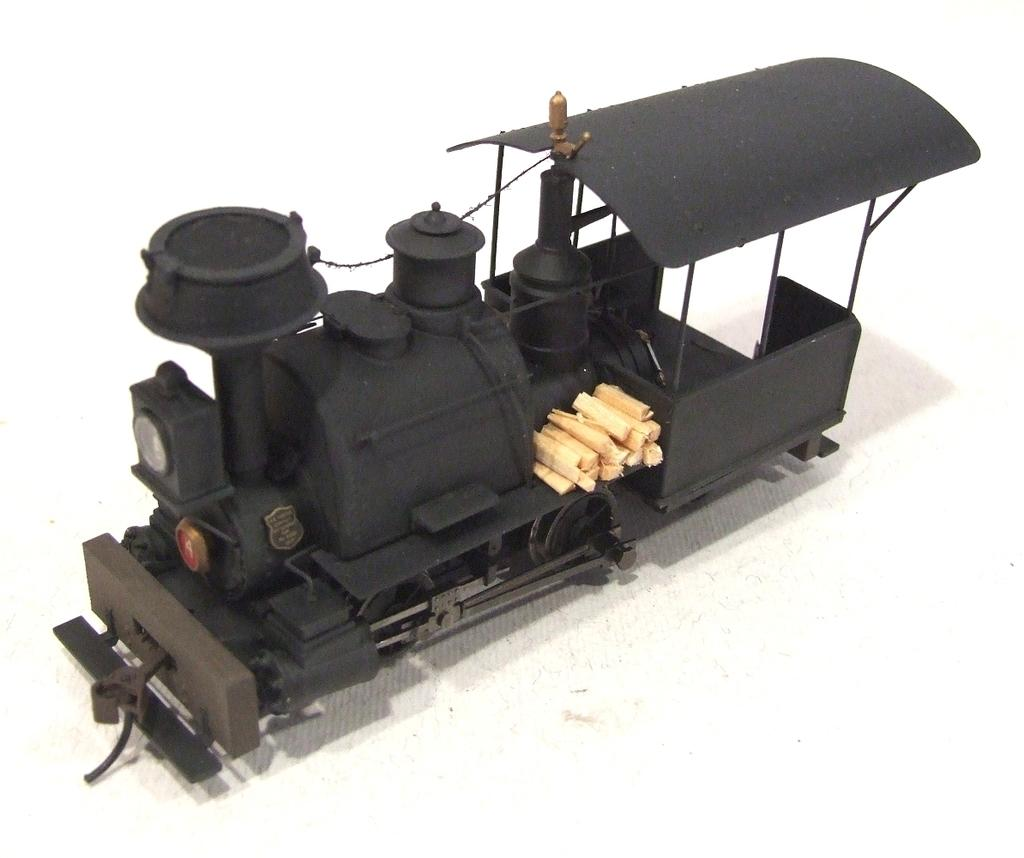What is the main subject of the image? The main subject of the image is the engine of a toy train. Where is the engine located? The engine is on a platform. What else can be seen on the platform in the image? There are wooden pieces on the platform. How are the wooden pieces positioned in relation to the engine? The wooden pieces are located at one side of the engine. What type of shop can be seen in the background of the image? There is no shop visible in the image; it only features the engine of a toy train, a platform, and wooden pieces. How many daughters are present in the image? There are no people, including daughters, present in the image. 